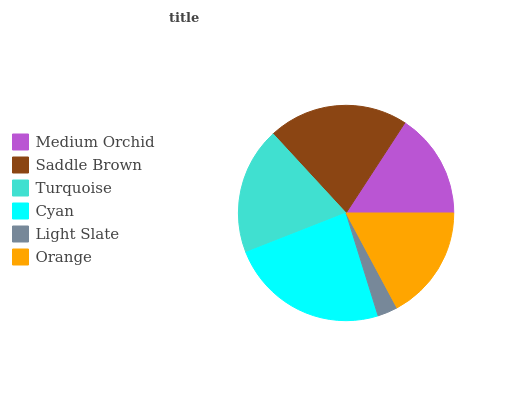Is Light Slate the minimum?
Answer yes or no. Yes. Is Cyan the maximum?
Answer yes or no. Yes. Is Saddle Brown the minimum?
Answer yes or no. No. Is Saddle Brown the maximum?
Answer yes or no. No. Is Saddle Brown greater than Medium Orchid?
Answer yes or no. Yes. Is Medium Orchid less than Saddle Brown?
Answer yes or no. Yes. Is Medium Orchid greater than Saddle Brown?
Answer yes or no. No. Is Saddle Brown less than Medium Orchid?
Answer yes or no. No. Is Turquoise the high median?
Answer yes or no. Yes. Is Orange the low median?
Answer yes or no. Yes. Is Orange the high median?
Answer yes or no. No. Is Saddle Brown the low median?
Answer yes or no. No. 